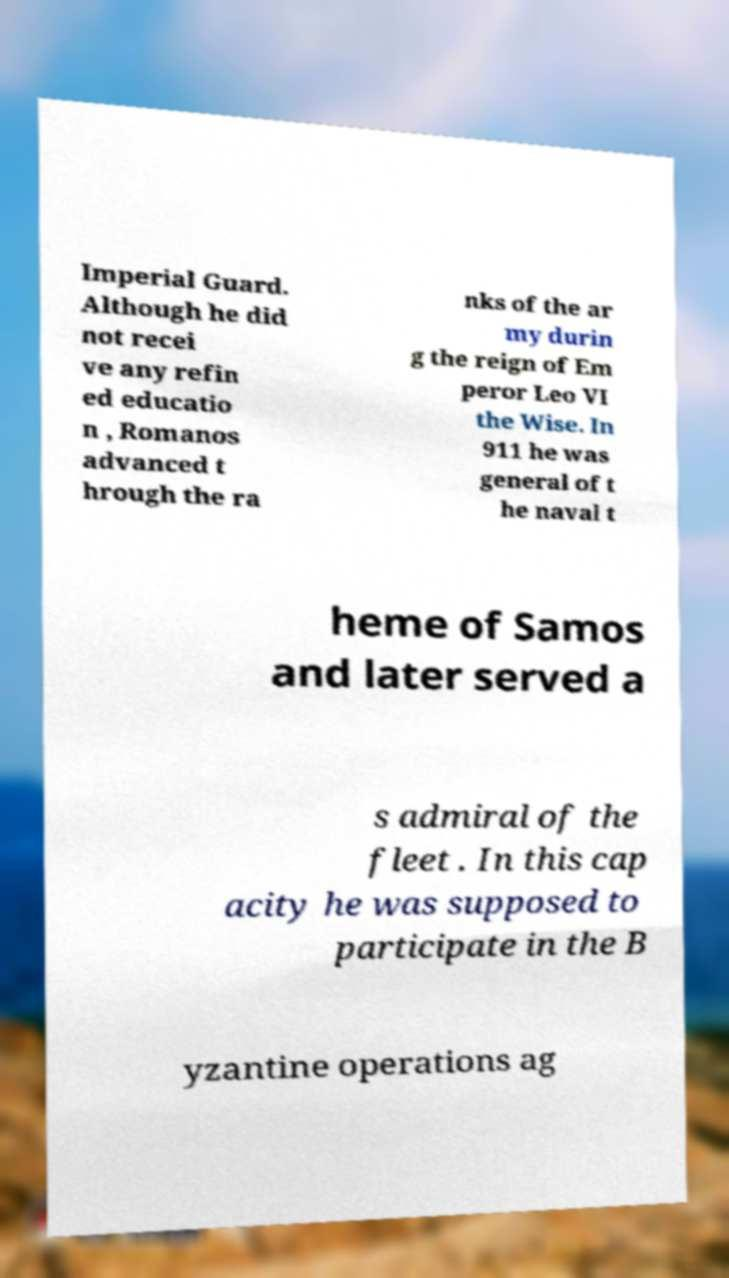Can you read and provide the text displayed in the image?This photo seems to have some interesting text. Can you extract and type it out for me? Imperial Guard. Although he did not recei ve any refin ed educatio n , Romanos advanced t hrough the ra nks of the ar my durin g the reign of Em peror Leo VI the Wise. In 911 he was general of t he naval t heme of Samos and later served a s admiral of the fleet . In this cap acity he was supposed to participate in the B yzantine operations ag 